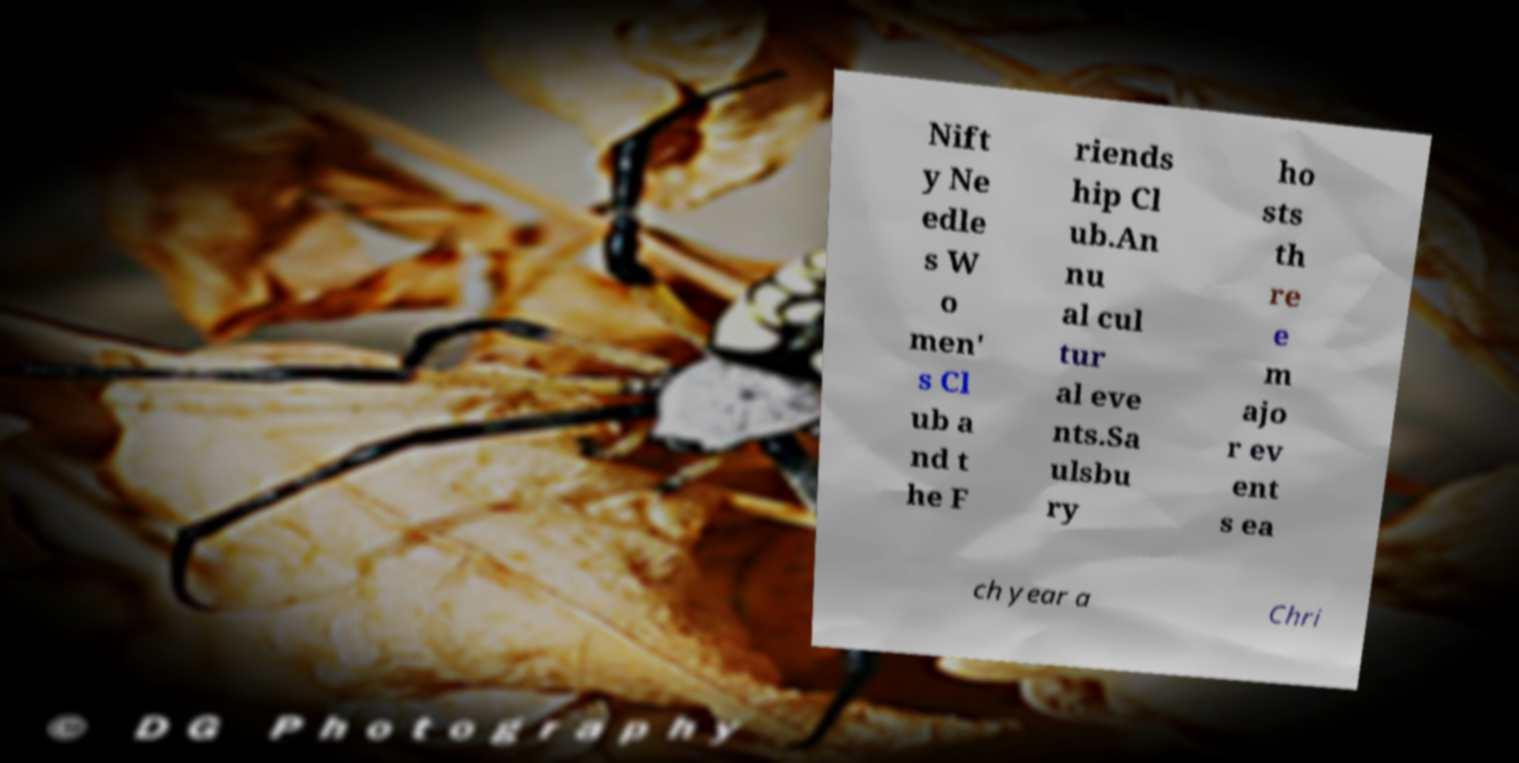There's text embedded in this image that I need extracted. Can you transcribe it verbatim? Nift y Ne edle s W o men' s Cl ub a nd t he F riends hip Cl ub.An nu al cul tur al eve nts.Sa ulsbu ry ho sts th re e m ajo r ev ent s ea ch year a Chri 